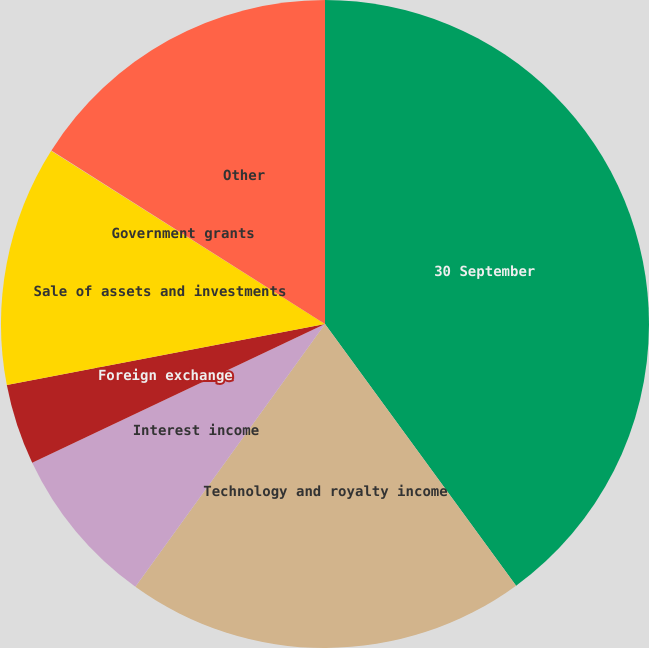<chart> <loc_0><loc_0><loc_500><loc_500><pie_chart><fcel>30 September<fcel>Technology and royalty income<fcel>Interest income<fcel>Foreign exchange<fcel>Sale of assets and investments<fcel>Government grants<fcel>Other<nl><fcel>39.96%<fcel>19.99%<fcel>8.01%<fcel>4.02%<fcel>12.0%<fcel>0.02%<fcel>16.0%<nl></chart> 